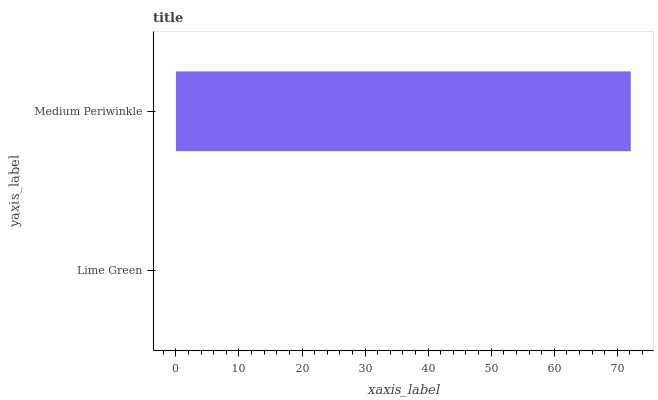Is Lime Green the minimum?
Answer yes or no. Yes. Is Medium Periwinkle the maximum?
Answer yes or no. Yes. Is Medium Periwinkle the minimum?
Answer yes or no. No. Is Medium Periwinkle greater than Lime Green?
Answer yes or no. Yes. Is Lime Green less than Medium Periwinkle?
Answer yes or no. Yes. Is Lime Green greater than Medium Periwinkle?
Answer yes or no. No. Is Medium Periwinkle less than Lime Green?
Answer yes or no. No. Is Medium Periwinkle the high median?
Answer yes or no. Yes. Is Lime Green the low median?
Answer yes or no. Yes. Is Lime Green the high median?
Answer yes or no. No. Is Medium Periwinkle the low median?
Answer yes or no. No. 